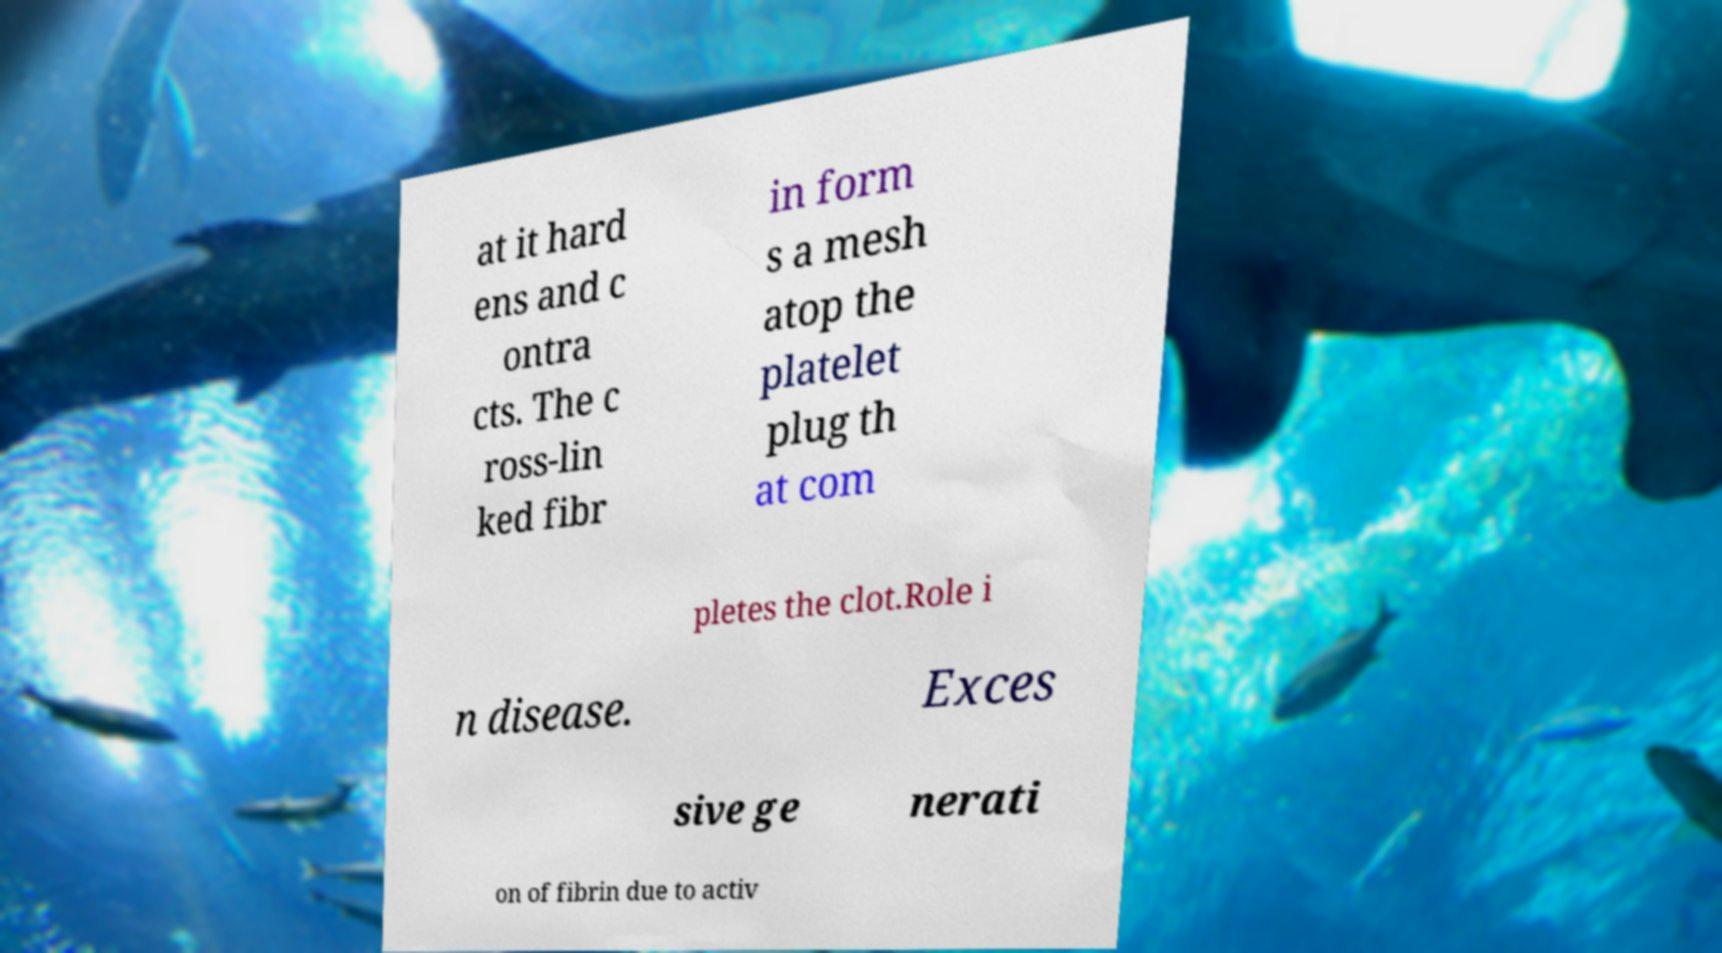Could you extract and type out the text from this image? at it hard ens and c ontra cts. The c ross-lin ked fibr in form s a mesh atop the platelet plug th at com pletes the clot.Role i n disease. Exces sive ge nerati on of fibrin due to activ 